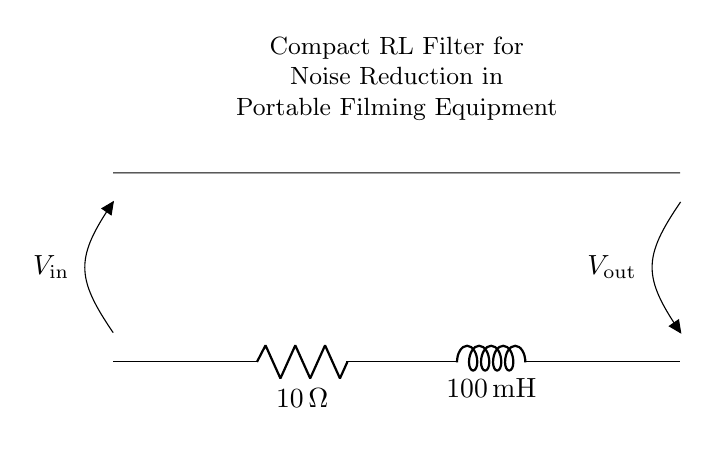What is the resistance value in this circuit? The resistance is labeled as R in the circuit diagram, with a value of 10 ohms.
Answer: 10 ohms What is the inductance value in this circuit? The inductance is labeled as L in the circuit diagram, with a value of 100 millihenries.
Answer: 100 millihenries What does V_in represent in this circuit? V_in is marked at one end of the circuit, indicating the input voltage to the RL filter circuit.
Answer: Input voltage What is the function of this compact RL filter circuit? The primary purpose of this circuit is to reduce noise, especially in portable filming equipment, by filtering out unwanted high-frequency signals.
Answer: Noise reduction How many components are there in this circuit? There are two main components in the circuit: one resistor and one inductor, totaling two components.
Answer: Two components What type of filter does this RL circuit represent? This circuit operates as a low-pass filter, allowing low-frequency signals to pass while attenuating high-frequency noise.
Answer: Low-pass filter How do the resistor and inductor interact in this circuit? The resistor limits the current while the inductor stores energy; together they determine the filter's frequency response and stability.
Answer: Current limiting and energy storage 